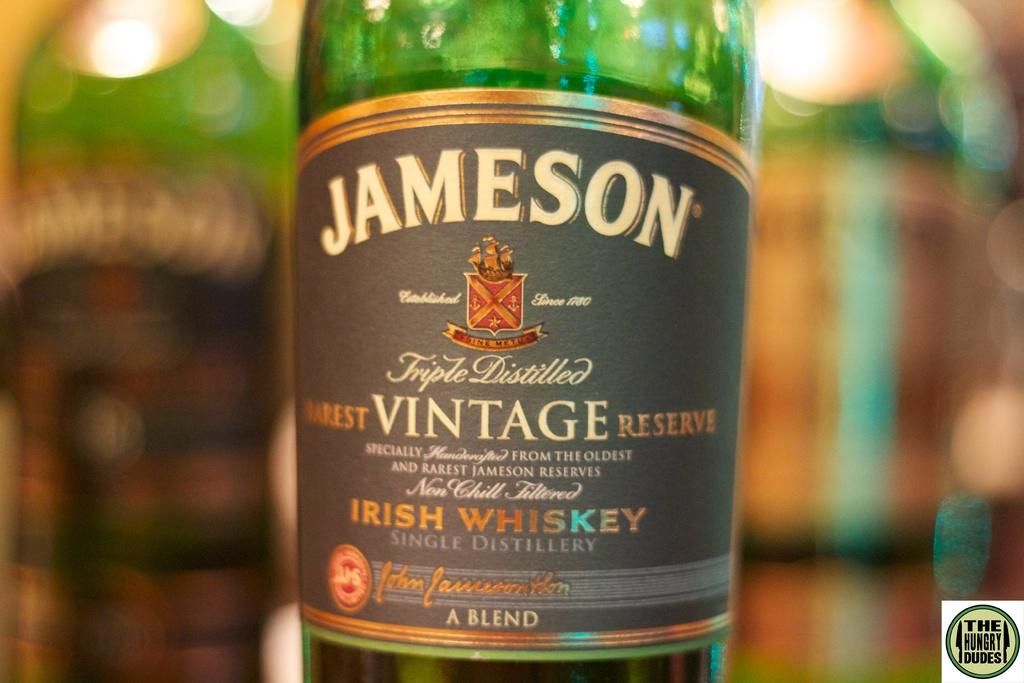<image>
Provide a brief description of the given image. A bottle of Jameson is labeled as vintage. 